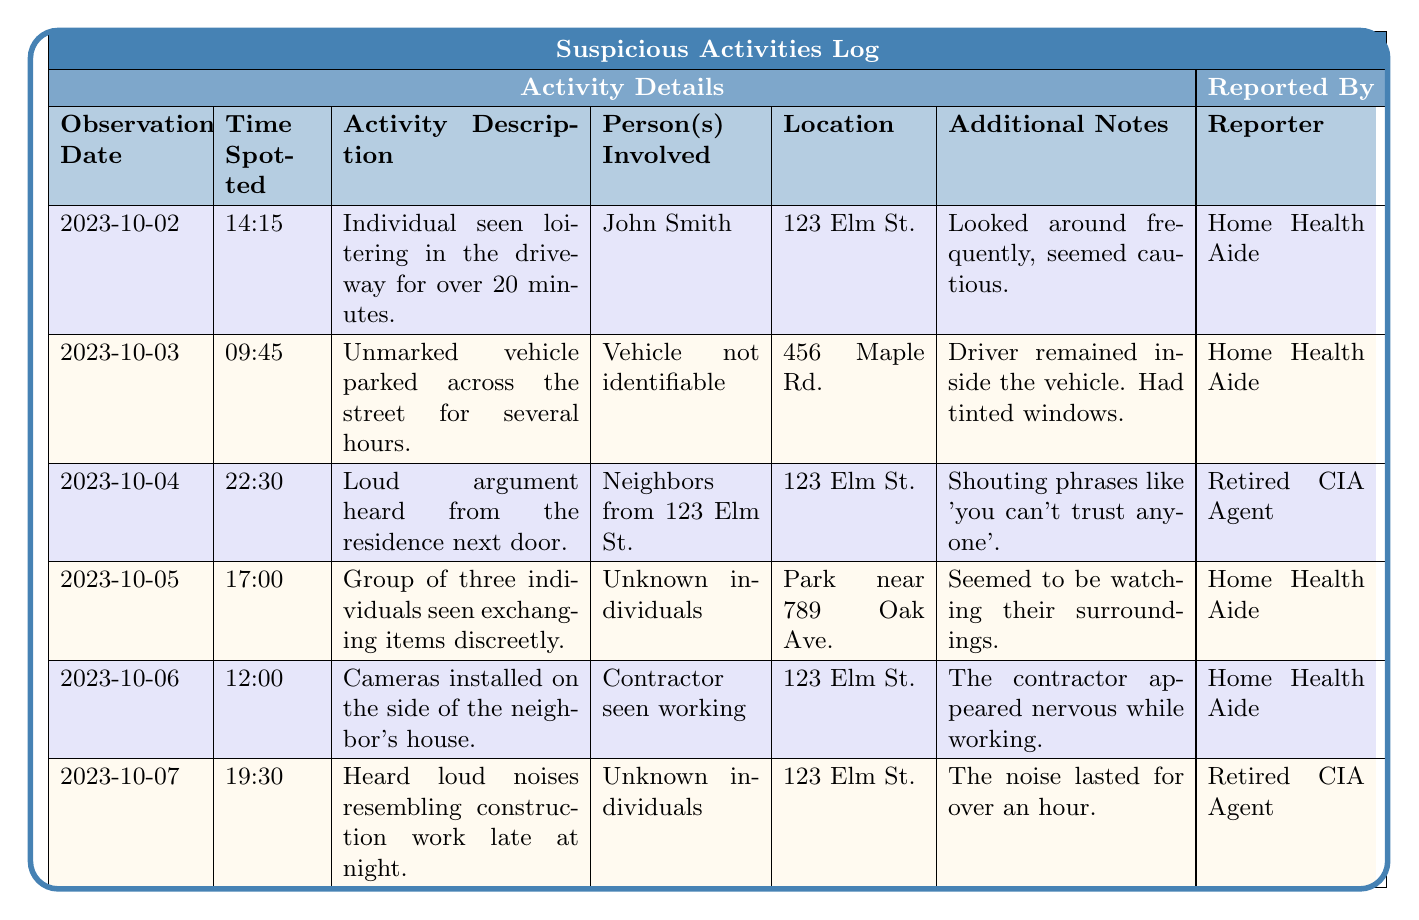What is the most recent suspicious activity reported? The most recent entry is from 2023-10-07, which describes loud noises resembling construction work at 123 Elm St.
Answer: 2023-10-07 How many observations were reported by the Home Health Aide? There are four entries where the reporter is listed as the Home Health Aide, specifically for the dates 2023-10-02, 2023-10-03, 2023-10-05, and 2023-10-06.
Answer: 4 Was there a report of an argument from the neighbors? Yes, there was a report on 2023-10-04 of a loud argument heard from the residence next door involving neighbors from 123 Elm St.
Answer: Yes What was the location of the activity that involved a group of individuals? The group of three individuals exchanging items was spotted at the park near 789 Oak Ave.
Answer: Park near 789 Oak Ave How many different locations are mentioned in the observations? The locations mentioned in the log are 123 Elm St., 456 Maple Rd., and Park near 789 Oak Ave., totaling three different locations.
Answer: 3 Which observation involved a contractor, and what was noted about their behavior? The observation on 2023-10-06 involved a contractor working on the side of the neighbor's house, noted to appear nervous while working.
Answer: 2023-10-06; nervous behavior Are there reports of any identifiable individuals involved in suspicious activities? Yes, John Smith is identified in one report while several entries mention unknown individuals or a vehicle not identifiable.
Answer: Yes What time did the loud argument occur? The loud argument was reported at 22:30 (10:30 PM) on 2023-10-04.
Answer: 22:30 What kind of vehicle was involved in the report from 2023-10-03? The report mentioned an unmarked vehicle that was not identifiable.
Answer: Unmarked vehicle Which observation reported suspicious behaviors related to watching the surroundings? The entry on 2023-10-05 noted a group of three individuals exchanging items discreetly and seemed to be watching their surroundings.
Answer: 2023-10-05 